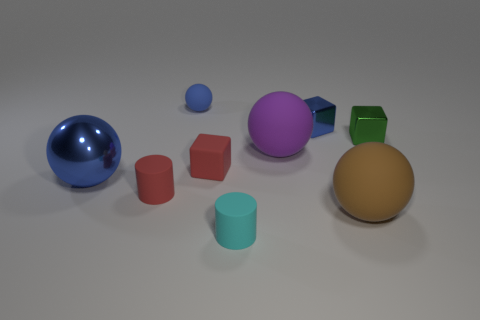Do the cyan rubber object and the metal thing that is in front of the tiny green metal object have the same size?
Offer a terse response. No. What color is the matte ball to the left of the tiny rubber cylinder in front of the ball that is in front of the metallic sphere?
Provide a succinct answer. Blue. Do the object in front of the large brown matte object and the large purple sphere have the same material?
Provide a short and direct response. Yes. How many other things are made of the same material as the purple ball?
Offer a terse response. 5. What material is the green cube that is the same size as the blue cube?
Make the answer very short. Metal. Do the small red matte object that is to the left of the blue rubber object and the blue metallic object that is on the right side of the red block have the same shape?
Offer a terse response. No. What is the shape of the purple rubber thing that is the same size as the brown thing?
Provide a succinct answer. Sphere. Do the tiny blue object to the right of the small rubber cube and the cyan cylinder that is in front of the large brown matte ball have the same material?
Give a very brief answer. No. Is there a large brown matte thing that is to the left of the small blue object to the left of the small cyan thing?
Provide a short and direct response. No. There is another small cylinder that is made of the same material as the cyan cylinder; what is its color?
Your answer should be compact. Red. 